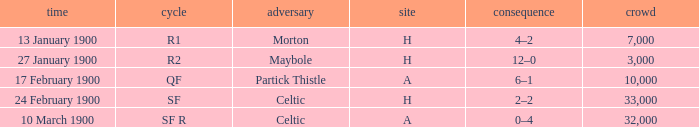Who played against in venue a on 17 february 1900? Partick Thistle. 